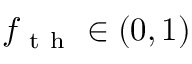Convert formula to latex. <formula><loc_0><loc_0><loc_500><loc_500>f _ { t h } \in ( 0 , 1 )</formula> 